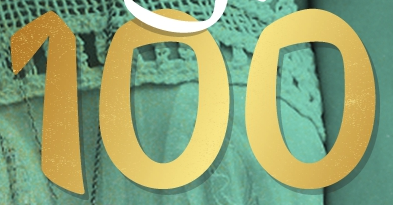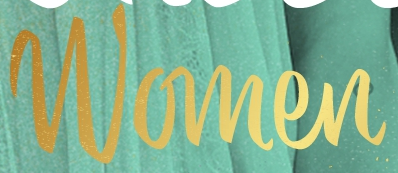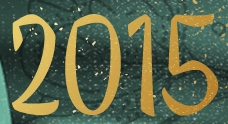Identify the words shown in these images in order, separated by a semicolon. 100; Women; 2015 